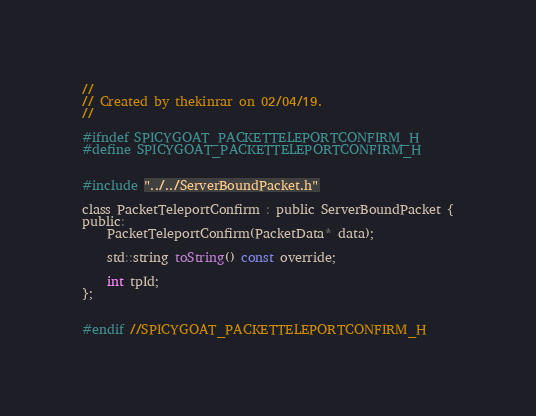<code> <loc_0><loc_0><loc_500><loc_500><_C_>//
// Created by thekinrar on 02/04/19.
//

#ifndef SPICYGOAT_PACKETTELEPORTCONFIRM_H
#define SPICYGOAT_PACKETTELEPORTCONFIRM_H


#include "../../ServerBoundPacket.h"

class PacketTeleportConfirm : public ServerBoundPacket {
public:
    PacketTeleportConfirm(PacketData* data);

    std::string toString() const override;

    int tpId;
};


#endif //SPICYGOAT_PACKETTELEPORTCONFIRM_H
</code> 